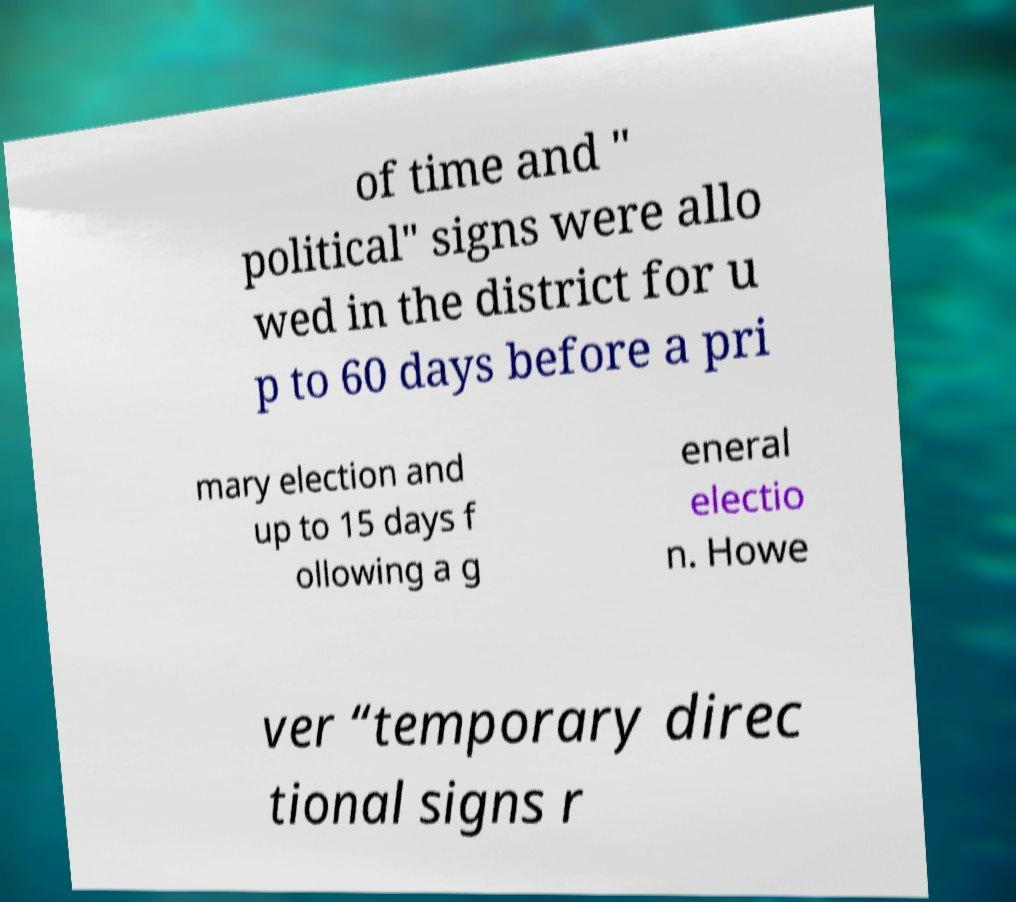Could you assist in decoding the text presented in this image and type it out clearly? of time and " political" signs were allo wed in the district for u p to 60 days before a pri mary election and up to 15 days f ollowing a g eneral electio n. Howe ver “temporary direc tional signs r 